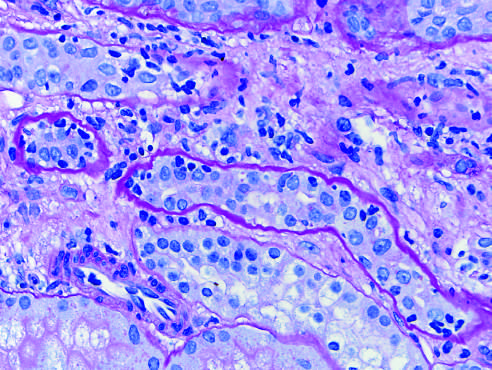what are outlined by wavy basement membranes?
Answer the question using a single word or phrase. Collapsed tubules 